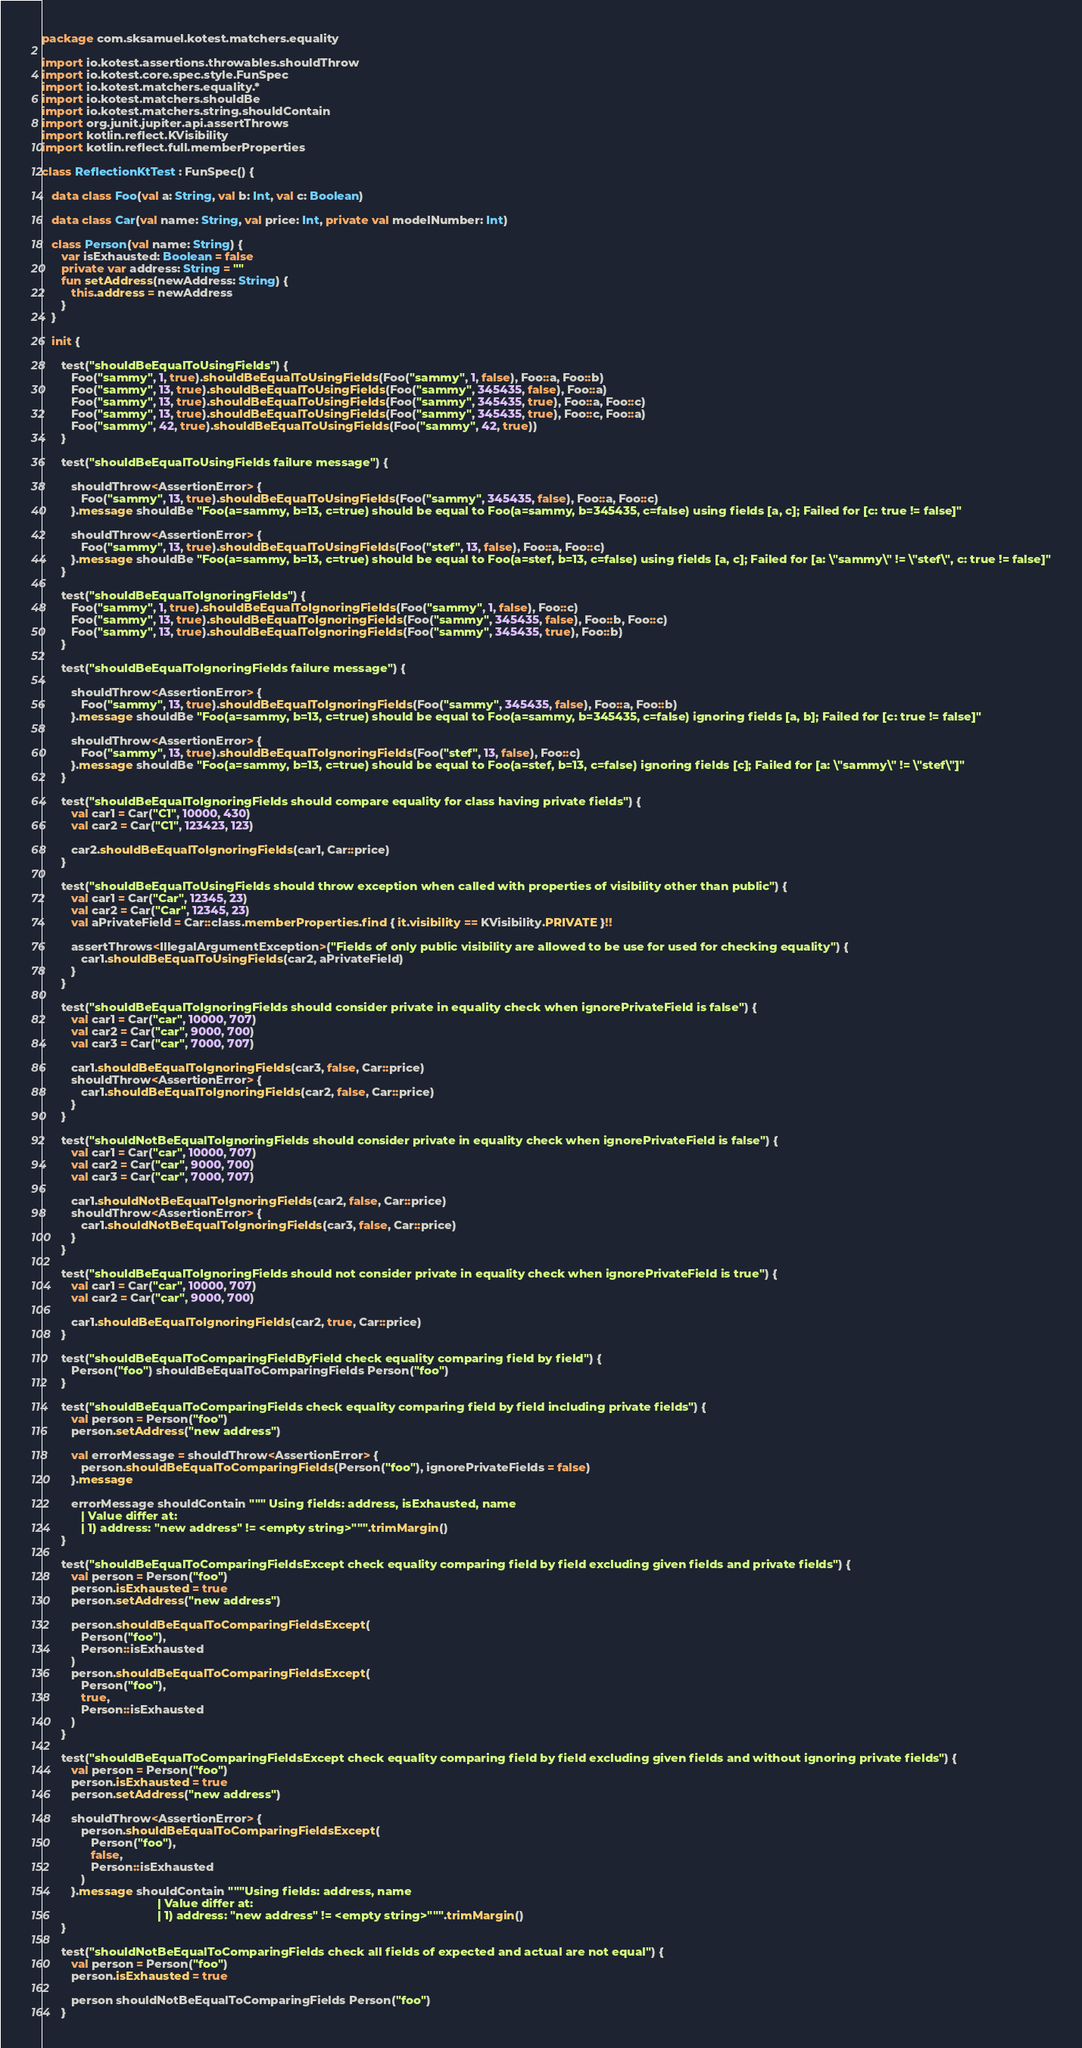Convert code to text. <code><loc_0><loc_0><loc_500><loc_500><_Kotlin_>package com.sksamuel.kotest.matchers.equality

import io.kotest.assertions.throwables.shouldThrow
import io.kotest.core.spec.style.FunSpec
import io.kotest.matchers.equality.*
import io.kotest.matchers.shouldBe
import io.kotest.matchers.string.shouldContain
import org.junit.jupiter.api.assertThrows
import kotlin.reflect.KVisibility
import kotlin.reflect.full.memberProperties

class ReflectionKtTest : FunSpec() {

   data class Foo(val a: String, val b: Int, val c: Boolean)

   data class Car(val name: String, val price: Int, private val modelNumber: Int)

   class Person(val name: String) {
      var isExhausted: Boolean = false
      private var address: String = ""
      fun setAddress(newAddress: String) {
         this.address = newAddress
      }
   }

   init {

      test("shouldBeEqualToUsingFields") {
         Foo("sammy", 1, true).shouldBeEqualToUsingFields(Foo("sammy", 1, false), Foo::a, Foo::b)
         Foo("sammy", 13, true).shouldBeEqualToUsingFields(Foo("sammy", 345435, false), Foo::a)
         Foo("sammy", 13, true).shouldBeEqualToUsingFields(Foo("sammy", 345435, true), Foo::a, Foo::c)
         Foo("sammy", 13, true).shouldBeEqualToUsingFields(Foo("sammy", 345435, true), Foo::c, Foo::a)
         Foo("sammy", 42, true).shouldBeEqualToUsingFields(Foo("sammy", 42, true))
      }

      test("shouldBeEqualToUsingFields failure message") {

         shouldThrow<AssertionError> {
            Foo("sammy", 13, true).shouldBeEqualToUsingFields(Foo("sammy", 345435, false), Foo::a, Foo::c)
         }.message shouldBe "Foo(a=sammy, b=13, c=true) should be equal to Foo(a=sammy, b=345435, c=false) using fields [a, c]; Failed for [c: true != false]"

         shouldThrow<AssertionError> {
            Foo("sammy", 13, true).shouldBeEqualToUsingFields(Foo("stef", 13, false), Foo::a, Foo::c)
         }.message shouldBe "Foo(a=sammy, b=13, c=true) should be equal to Foo(a=stef, b=13, c=false) using fields [a, c]; Failed for [a: \"sammy\" != \"stef\", c: true != false]"
      }

      test("shouldBeEqualToIgnoringFields") {
         Foo("sammy", 1, true).shouldBeEqualToIgnoringFields(Foo("sammy", 1, false), Foo::c)
         Foo("sammy", 13, true).shouldBeEqualToIgnoringFields(Foo("sammy", 345435, false), Foo::b, Foo::c)
         Foo("sammy", 13, true).shouldBeEqualToIgnoringFields(Foo("sammy", 345435, true), Foo::b)
      }

      test("shouldBeEqualToIgnoringFields failure message") {

         shouldThrow<AssertionError> {
            Foo("sammy", 13, true).shouldBeEqualToIgnoringFields(Foo("sammy", 345435, false), Foo::a, Foo::b)
         }.message shouldBe "Foo(a=sammy, b=13, c=true) should be equal to Foo(a=sammy, b=345435, c=false) ignoring fields [a, b]; Failed for [c: true != false]"

         shouldThrow<AssertionError> {
            Foo("sammy", 13, true).shouldBeEqualToIgnoringFields(Foo("stef", 13, false), Foo::c)
         }.message shouldBe "Foo(a=sammy, b=13, c=true) should be equal to Foo(a=stef, b=13, c=false) ignoring fields [c]; Failed for [a: \"sammy\" != \"stef\"]"
      }

      test("shouldBeEqualToIgnoringFields should compare equality for class having private fields") {
         val car1 = Car("C1", 10000, 430)
         val car2 = Car("C1", 123423, 123)

         car2.shouldBeEqualToIgnoringFields(car1, Car::price)
      }

      test("shouldBeEqualToUsingFields should throw exception when called with properties of visibility other than public") {
         val car1 = Car("Car", 12345, 23)
         val car2 = Car("Car", 12345, 23)
         val aPrivateField = Car::class.memberProperties.find { it.visibility == KVisibility.PRIVATE }!!

         assertThrows<IllegalArgumentException>("Fields of only public visibility are allowed to be use for used for checking equality") {
            car1.shouldBeEqualToUsingFields(car2, aPrivateField)
         }
      }

      test("shouldBeEqualToIgnoringFields should consider private in equality check when ignorePrivateField is false") {
         val car1 = Car("car", 10000, 707)
         val car2 = Car("car", 9000, 700)
         val car3 = Car("car", 7000, 707)

         car1.shouldBeEqualToIgnoringFields(car3, false, Car::price)
         shouldThrow<AssertionError> {
            car1.shouldBeEqualToIgnoringFields(car2, false, Car::price)
         }
      }

      test("shouldNotBeEqualToIgnoringFields should consider private in equality check when ignorePrivateField is false") {
         val car1 = Car("car", 10000, 707)
         val car2 = Car("car", 9000, 700)
         val car3 = Car("car", 7000, 707)

         car1.shouldNotBeEqualToIgnoringFields(car2, false, Car::price)
         shouldThrow<AssertionError> {
            car1.shouldNotBeEqualToIgnoringFields(car3, false, Car::price)
         }
      }

      test("shouldBeEqualToIgnoringFields should not consider private in equality check when ignorePrivateField is true") {
         val car1 = Car("car", 10000, 707)
         val car2 = Car("car", 9000, 700)

         car1.shouldBeEqualToIgnoringFields(car2, true, Car::price)
      }

      test("shouldBeEqualToComparingFieldByField check equality comparing field by field") {
         Person("foo") shouldBeEqualToComparingFields Person("foo")
      }

      test("shouldBeEqualToComparingFields check equality comparing field by field including private fields") {
         val person = Person("foo")
         person.setAddress("new address")

         val errorMessage = shouldThrow<AssertionError> {
            person.shouldBeEqualToComparingFields(Person("foo"), ignorePrivateFields = false)
         }.message

         errorMessage shouldContain """ Using fields: address, isExhausted, name
            | Value differ at:
            | 1) address: "new address" != <empty string>""".trimMargin()
      }

      test("shouldBeEqualToComparingFieldsExcept check equality comparing field by field excluding given fields and private fields") {
         val person = Person("foo")
         person.isExhausted = true
         person.setAddress("new address")

         person.shouldBeEqualToComparingFieldsExcept(
            Person("foo"),
            Person::isExhausted
         )
         person.shouldBeEqualToComparingFieldsExcept(
            Person("foo"),
            true,
            Person::isExhausted
         )
      }

      test("shouldBeEqualToComparingFieldsExcept check equality comparing field by field excluding given fields and without ignoring private fields") {
         val person = Person("foo")
         person.isExhausted = true
         person.setAddress("new address")

         shouldThrow<AssertionError> {
            person.shouldBeEqualToComparingFieldsExcept(
               Person("foo"),
               false,
               Person::isExhausted
            )
         }.message shouldContain """Using fields: address, name
                                   | Value differ at:
                                   | 1) address: "new address" != <empty string>""".trimMargin()
      }

      test("shouldNotBeEqualToComparingFields check all fields of expected and actual are not equal") {
         val person = Person("foo")
         person.isExhausted = true

         person shouldNotBeEqualToComparingFields Person("foo")
      }
</code> 